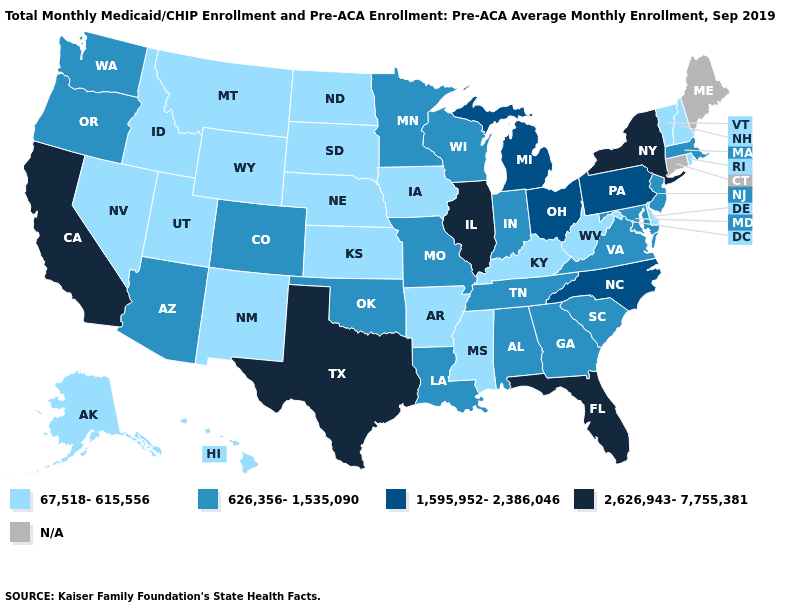What is the highest value in the South ?
Concise answer only. 2,626,943-7,755,381. Name the states that have a value in the range 1,595,952-2,386,046?
Give a very brief answer. Michigan, North Carolina, Ohio, Pennsylvania. What is the value of North Dakota?
Short answer required. 67,518-615,556. What is the lowest value in states that border Nevada?
Give a very brief answer. 67,518-615,556. What is the value of Kentucky?
Concise answer only. 67,518-615,556. Which states have the lowest value in the South?
Be succinct. Arkansas, Delaware, Kentucky, Mississippi, West Virginia. Name the states that have a value in the range 626,356-1,535,090?
Be succinct. Alabama, Arizona, Colorado, Georgia, Indiana, Louisiana, Maryland, Massachusetts, Minnesota, Missouri, New Jersey, Oklahoma, Oregon, South Carolina, Tennessee, Virginia, Washington, Wisconsin. What is the value of Utah?
Write a very short answer. 67,518-615,556. Name the states that have a value in the range N/A?
Give a very brief answer. Connecticut, Maine. What is the lowest value in the USA?
Be succinct. 67,518-615,556. Does New York have the highest value in the USA?
Quick response, please. Yes. What is the highest value in the USA?
Give a very brief answer. 2,626,943-7,755,381. What is the value of Hawaii?
Quick response, please. 67,518-615,556. What is the value of Michigan?
Write a very short answer. 1,595,952-2,386,046. 